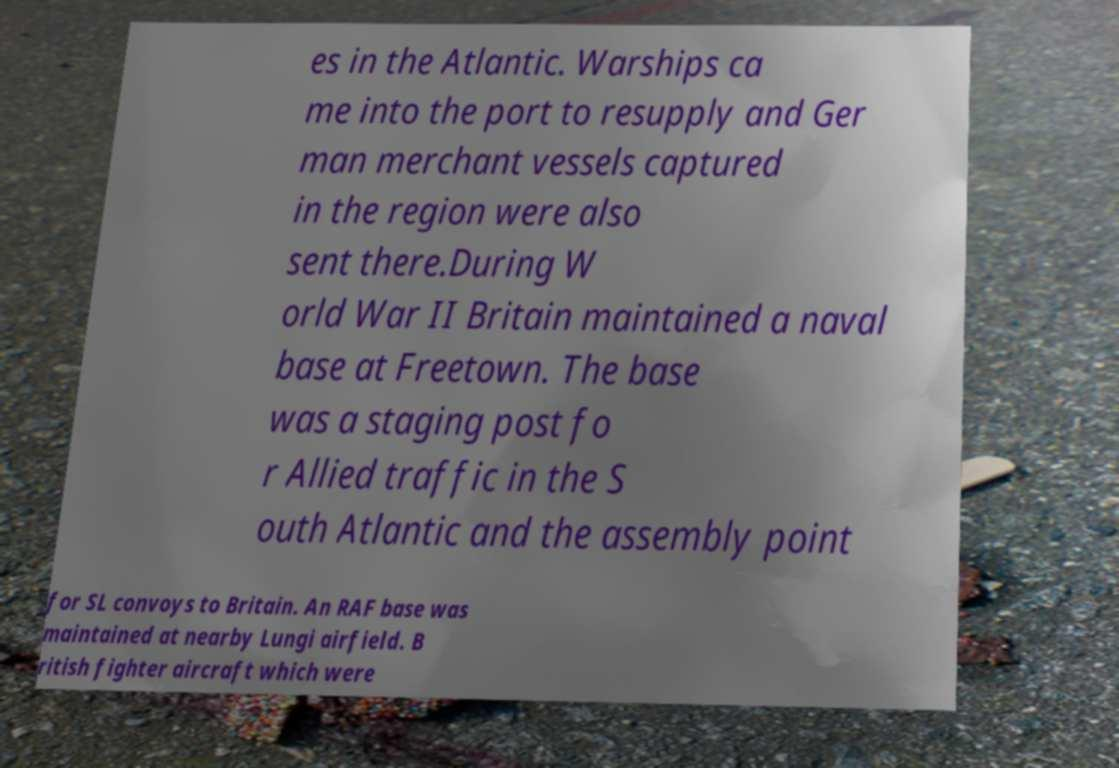Can you read and provide the text displayed in the image?This photo seems to have some interesting text. Can you extract and type it out for me? es in the Atlantic. Warships ca me into the port to resupply and Ger man merchant vessels captured in the region were also sent there.During W orld War II Britain maintained a naval base at Freetown. The base was a staging post fo r Allied traffic in the S outh Atlantic and the assembly point for SL convoys to Britain. An RAF base was maintained at nearby Lungi airfield. B ritish fighter aircraft which were 